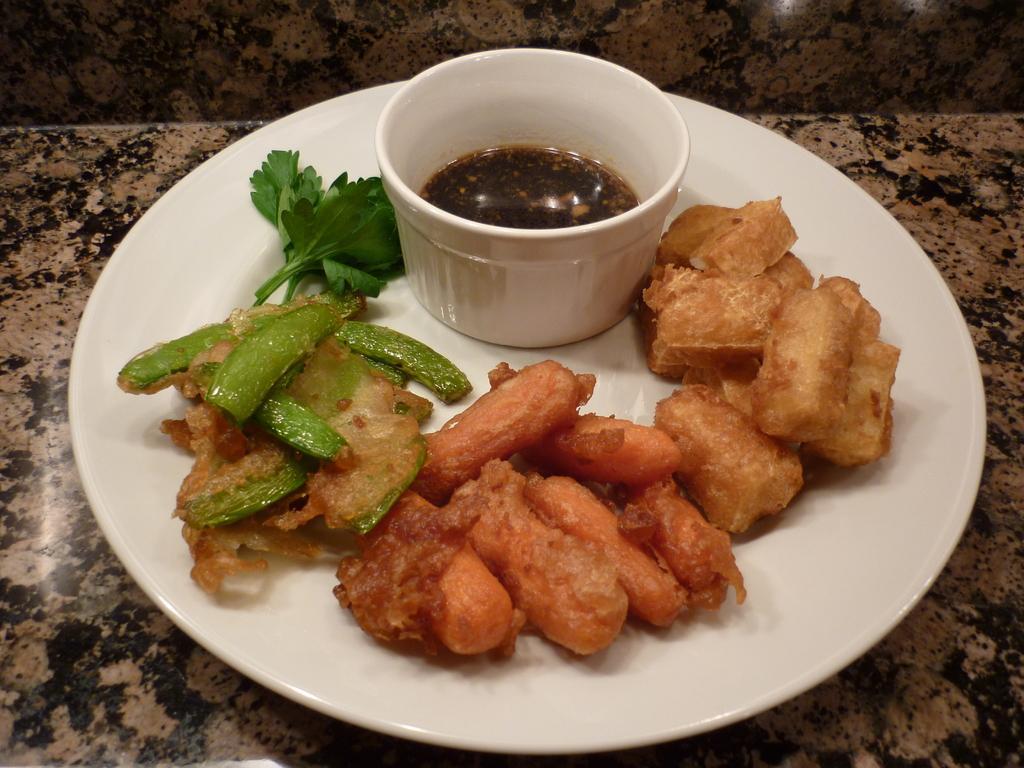How would you summarize this image in a sentence or two? This picture is clicked inside. In the center there is a white color platter containing some food items and a white color bowl of a liquid and the platter is placed on the top of the table. 